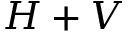<formula> <loc_0><loc_0><loc_500><loc_500>H + V</formula> 